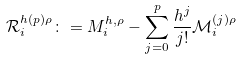<formula> <loc_0><loc_0><loc_500><loc_500>\mathcal { R } ^ { h ( p ) \rho } _ { i } \colon = M ^ { h , \rho } _ { i } - \sum _ { j = 0 } ^ { p } \frac { h ^ { j } } { j ! } \mathcal { M } ^ { ( j ) \rho } _ { i }</formula> 